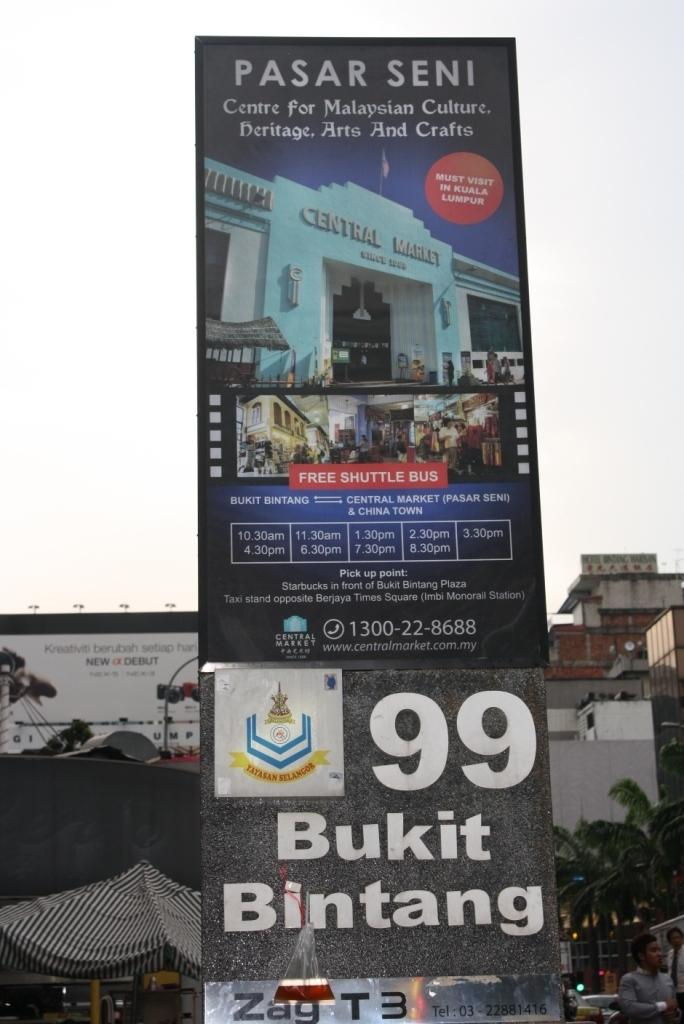<image>
Present a compact description of the photo's key features. Banners advertising a free shuttle bus to the Pasar Seni stand in the square 